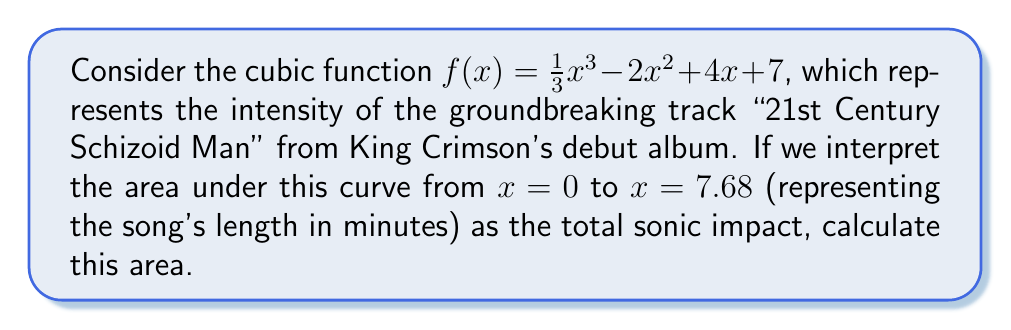Can you answer this question? To find the area under the curve, we need to integrate the function from 0 to 7.68. Let's approach this step-by-step:

1) The integral we need to calculate is:

   $$\int_0^{7.68} (\frac{1}{3}x^3 - 2x^2 + 4x + 7) dx$$

2) Integrate each term:
   $$[\frac{1}{12}x^4 - \frac{2}{3}x^3 + 2x^2 + 7x]_0^{7.68}$$

3) Evaluate at the upper and lower bounds:
   
   Upper bound (7.68):
   $$\frac{1}{12}(7.68)^4 - \frac{2}{3}(7.68)^3 + 2(7.68)^2 + 7(7.68)$$
   
   Lower bound (0):
   $$\frac{1}{12}(0)^4 - \frac{2}{3}(0)^3 + 2(0)^2 + 7(0) = 0$$

4) Subtract the lower bound from the upper bound:

   $$\frac{1}{12}(7.68)^4 - \frac{2}{3}(7.68)^3 + 2(7.68)^2 + 7(7.68) - 0$$

5) Calculate:
   $$\frac{1}{12}(3481.2716) - \frac{2}{3}(452.9984) + 2(58.9824) + 53.76$$
   $$= 290.1060 - 301.9989 + 117.9648 + 53.76$$
   $$= 159.8319$$

Thus, the area under the curve from 0 to 7.68 is approximately 159.8319 units squared.
Answer: 159.8319 square units 